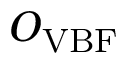<formula> <loc_0><loc_0><loc_500><loc_500>O _ { V B F }</formula> 